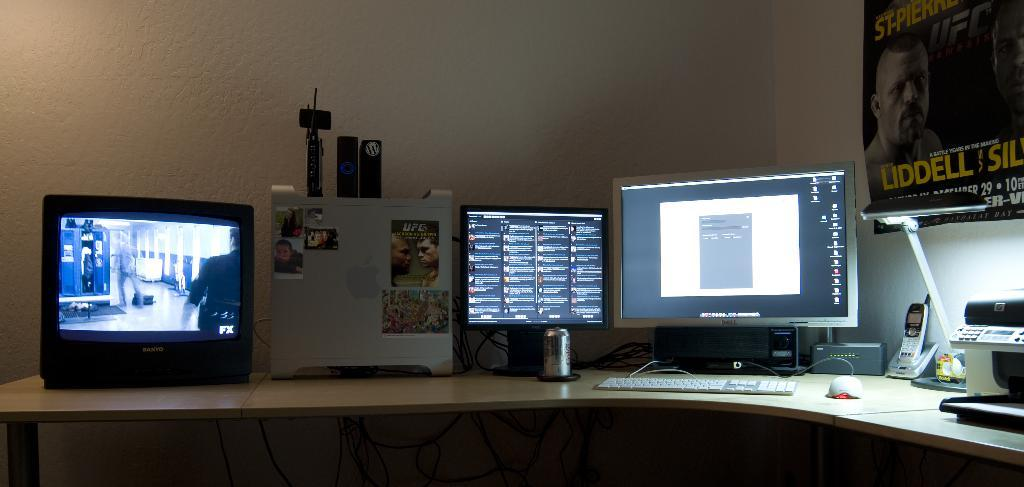What type of device is visible in the image? There is a screen, keyboard, and mouse in the image, which suggests a computer or laptop. What other electronic gadget is present in the image? There is a mobile in the image. Where are these electronic gadgets located? These items are on a table. What can be seen on the wall in the background of the image? There is a poster on the wall in the background. What type of breakfast is being prepared on the table in the image? There is no breakfast or any food preparation visible in the image; it features electronic gadgets on a table. Can you see any quicksand in the image? There is no quicksand present in the image. 